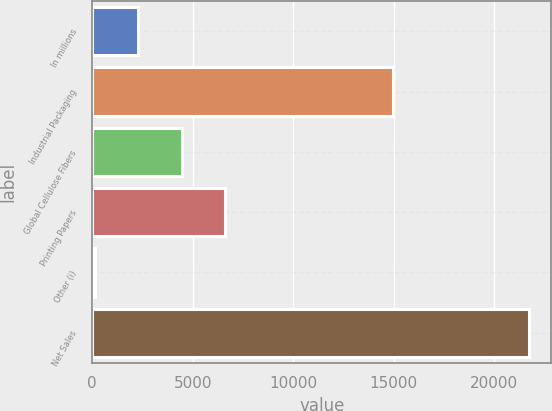Convert chart to OTSL. <chart><loc_0><loc_0><loc_500><loc_500><bar_chart><fcel>In millions<fcel>Industrial Packaging<fcel>Global Cellulose Fibers<fcel>Printing Papers<fcel>Other (i)<fcel>Net Sales<nl><fcel>2292.2<fcel>14946<fcel>4453.4<fcel>6614.6<fcel>131<fcel>21743<nl></chart> 